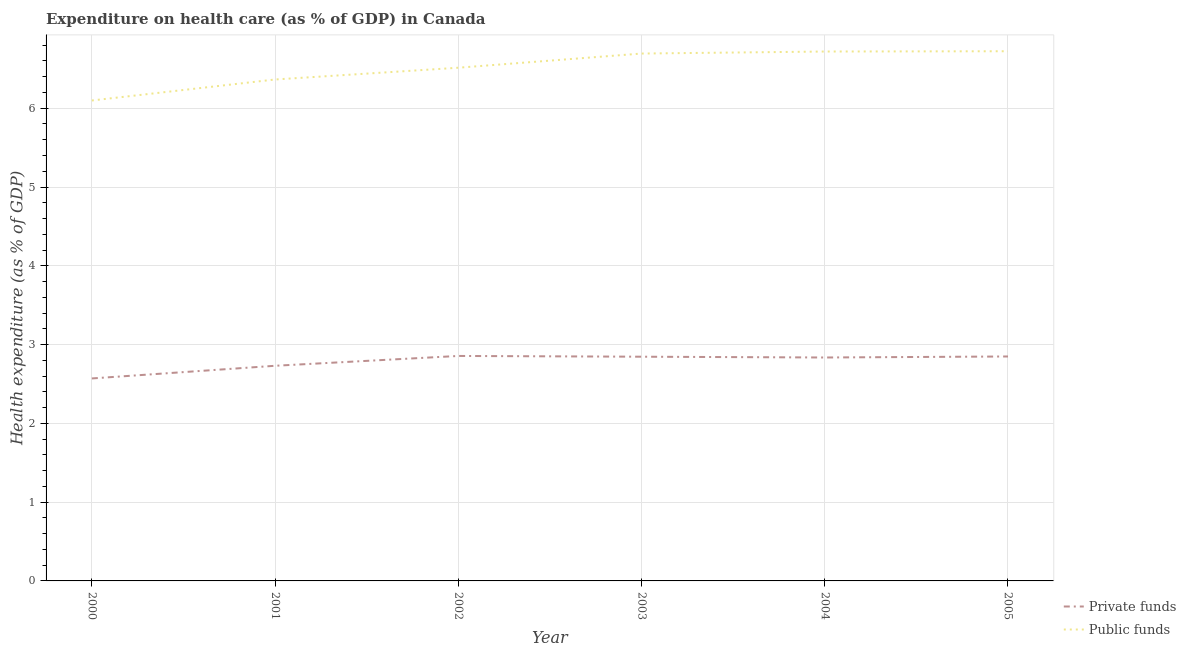What is the amount of public funds spent in healthcare in 2005?
Offer a very short reply. 6.72. Across all years, what is the maximum amount of private funds spent in healthcare?
Your answer should be compact. 2.86. Across all years, what is the minimum amount of private funds spent in healthcare?
Ensure brevity in your answer.  2.57. In which year was the amount of private funds spent in healthcare maximum?
Your response must be concise. 2002. In which year was the amount of public funds spent in healthcare minimum?
Ensure brevity in your answer.  2000. What is the total amount of private funds spent in healthcare in the graph?
Offer a very short reply. 16.69. What is the difference between the amount of private funds spent in healthcare in 2002 and that in 2004?
Make the answer very short. 0.02. What is the difference between the amount of private funds spent in healthcare in 2003 and the amount of public funds spent in healthcare in 2001?
Keep it short and to the point. -3.52. What is the average amount of public funds spent in healthcare per year?
Provide a succinct answer. 6.52. In the year 2000, what is the difference between the amount of private funds spent in healthcare and amount of public funds spent in healthcare?
Your response must be concise. -3.53. In how many years, is the amount of private funds spent in healthcare greater than 0.2 %?
Provide a succinct answer. 6. What is the ratio of the amount of private funds spent in healthcare in 2001 to that in 2002?
Keep it short and to the point. 0.96. Is the amount of public funds spent in healthcare in 2001 less than that in 2002?
Provide a succinct answer. Yes. What is the difference between the highest and the second highest amount of private funds spent in healthcare?
Offer a terse response. 0.01. What is the difference between the highest and the lowest amount of private funds spent in healthcare?
Provide a short and direct response. 0.29. In how many years, is the amount of public funds spent in healthcare greater than the average amount of public funds spent in healthcare taken over all years?
Give a very brief answer. 3. How many years are there in the graph?
Your answer should be compact. 6. Are the values on the major ticks of Y-axis written in scientific E-notation?
Make the answer very short. No. How are the legend labels stacked?
Your response must be concise. Vertical. What is the title of the graph?
Your answer should be very brief. Expenditure on health care (as % of GDP) in Canada. Does "Secondary" appear as one of the legend labels in the graph?
Give a very brief answer. No. What is the label or title of the Y-axis?
Provide a succinct answer. Health expenditure (as % of GDP). What is the Health expenditure (as % of GDP) of Private funds in 2000?
Provide a short and direct response. 2.57. What is the Health expenditure (as % of GDP) in Public funds in 2000?
Offer a very short reply. 6.1. What is the Health expenditure (as % of GDP) of Private funds in 2001?
Keep it short and to the point. 2.73. What is the Health expenditure (as % of GDP) in Public funds in 2001?
Your answer should be very brief. 6.36. What is the Health expenditure (as % of GDP) in Private funds in 2002?
Make the answer very short. 2.86. What is the Health expenditure (as % of GDP) in Public funds in 2002?
Your answer should be very brief. 6.51. What is the Health expenditure (as % of GDP) in Private funds in 2003?
Give a very brief answer. 2.85. What is the Health expenditure (as % of GDP) in Public funds in 2003?
Provide a succinct answer. 6.69. What is the Health expenditure (as % of GDP) of Private funds in 2004?
Your response must be concise. 2.84. What is the Health expenditure (as % of GDP) in Public funds in 2004?
Keep it short and to the point. 6.72. What is the Health expenditure (as % of GDP) of Private funds in 2005?
Ensure brevity in your answer.  2.85. What is the Health expenditure (as % of GDP) in Public funds in 2005?
Give a very brief answer. 6.72. Across all years, what is the maximum Health expenditure (as % of GDP) in Private funds?
Provide a succinct answer. 2.86. Across all years, what is the maximum Health expenditure (as % of GDP) of Public funds?
Your response must be concise. 6.72. Across all years, what is the minimum Health expenditure (as % of GDP) in Private funds?
Make the answer very short. 2.57. Across all years, what is the minimum Health expenditure (as % of GDP) in Public funds?
Keep it short and to the point. 6.1. What is the total Health expenditure (as % of GDP) of Private funds in the graph?
Your response must be concise. 16.69. What is the total Health expenditure (as % of GDP) in Public funds in the graph?
Make the answer very short. 39.12. What is the difference between the Health expenditure (as % of GDP) in Private funds in 2000 and that in 2001?
Provide a succinct answer. -0.16. What is the difference between the Health expenditure (as % of GDP) of Public funds in 2000 and that in 2001?
Provide a succinct answer. -0.27. What is the difference between the Health expenditure (as % of GDP) in Private funds in 2000 and that in 2002?
Ensure brevity in your answer.  -0.29. What is the difference between the Health expenditure (as % of GDP) of Public funds in 2000 and that in 2002?
Provide a short and direct response. -0.42. What is the difference between the Health expenditure (as % of GDP) of Private funds in 2000 and that in 2003?
Your answer should be very brief. -0.28. What is the difference between the Health expenditure (as % of GDP) in Public funds in 2000 and that in 2003?
Your response must be concise. -0.6. What is the difference between the Health expenditure (as % of GDP) of Private funds in 2000 and that in 2004?
Your answer should be compact. -0.27. What is the difference between the Health expenditure (as % of GDP) in Public funds in 2000 and that in 2004?
Provide a succinct answer. -0.62. What is the difference between the Health expenditure (as % of GDP) of Private funds in 2000 and that in 2005?
Your response must be concise. -0.28. What is the difference between the Health expenditure (as % of GDP) of Public funds in 2000 and that in 2005?
Give a very brief answer. -0.63. What is the difference between the Health expenditure (as % of GDP) of Private funds in 2001 and that in 2002?
Provide a short and direct response. -0.12. What is the difference between the Health expenditure (as % of GDP) in Public funds in 2001 and that in 2002?
Ensure brevity in your answer.  -0.15. What is the difference between the Health expenditure (as % of GDP) of Private funds in 2001 and that in 2003?
Your response must be concise. -0.12. What is the difference between the Health expenditure (as % of GDP) in Public funds in 2001 and that in 2003?
Your answer should be very brief. -0.33. What is the difference between the Health expenditure (as % of GDP) in Private funds in 2001 and that in 2004?
Keep it short and to the point. -0.11. What is the difference between the Health expenditure (as % of GDP) in Public funds in 2001 and that in 2004?
Your response must be concise. -0.35. What is the difference between the Health expenditure (as % of GDP) in Private funds in 2001 and that in 2005?
Offer a terse response. -0.12. What is the difference between the Health expenditure (as % of GDP) of Public funds in 2001 and that in 2005?
Give a very brief answer. -0.36. What is the difference between the Health expenditure (as % of GDP) in Private funds in 2002 and that in 2003?
Make the answer very short. 0.01. What is the difference between the Health expenditure (as % of GDP) of Public funds in 2002 and that in 2003?
Provide a succinct answer. -0.18. What is the difference between the Health expenditure (as % of GDP) of Private funds in 2002 and that in 2004?
Keep it short and to the point. 0.02. What is the difference between the Health expenditure (as % of GDP) in Public funds in 2002 and that in 2004?
Your response must be concise. -0.21. What is the difference between the Health expenditure (as % of GDP) of Private funds in 2002 and that in 2005?
Your response must be concise. 0.01. What is the difference between the Health expenditure (as % of GDP) of Public funds in 2002 and that in 2005?
Your answer should be very brief. -0.21. What is the difference between the Health expenditure (as % of GDP) of Private funds in 2003 and that in 2004?
Make the answer very short. 0.01. What is the difference between the Health expenditure (as % of GDP) of Public funds in 2003 and that in 2004?
Offer a very short reply. -0.03. What is the difference between the Health expenditure (as % of GDP) in Private funds in 2003 and that in 2005?
Your answer should be very brief. -0. What is the difference between the Health expenditure (as % of GDP) in Public funds in 2003 and that in 2005?
Offer a very short reply. -0.03. What is the difference between the Health expenditure (as % of GDP) in Private funds in 2004 and that in 2005?
Provide a short and direct response. -0.01. What is the difference between the Health expenditure (as % of GDP) of Public funds in 2004 and that in 2005?
Offer a very short reply. -0. What is the difference between the Health expenditure (as % of GDP) of Private funds in 2000 and the Health expenditure (as % of GDP) of Public funds in 2001?
Your response must be concise. -3.79. What is the difference between the Health expenditure (as % of GDP) in Private funds in 2000 and the Health expenditure (as % of GDP) in Public funds in 2002?
Make the answer very short. -3.94. What is the difference between the Health expenditure (as % of GDP) in Private funds in 2000 and the Health expenditure (as % of GDP) in Public funds in 2003?
Ensure brevity in your answer.  -4.12. What is the difference between the Health expenditure (as % of GDP) in Private funds in 2000 and the Health expenditure (as % of GDP) in Public funds in 2004?
Provide a succinct answer. -4.15. What is the difference between the Health expenditure (as % of GDP) in Private funds in 2000 and the Health expenditure (as % of GDP) in Public funds in 2005?
Give a very brief answer. -4.15. What is the difference between the Health expenditure (as % of GDP) in Private funds in 2001 and the Health expenditure (as % of GDP) in Public funds in 2002?
Give a very brief answer. -3.78. What is the difference between the Health expenditure (as % of GDP) of Private funds in 2001 and the Health expenditure (as % of GDP) of Public funds in 2003?
Make the answer very short. -3.96. What is the difference between the Health expenditure (as % of GDP) of Private funds in 2001 and the Health expenditure (as % of GDP) of Public funds in 2004?
Keep it short and to the point. -3.99. What is the difference between the Health expenditure (as % of GDP) of Private funds in 2001 and the Health expenditure (as % of GDP) of Public funds in 2005?
Give a very brief answer. -3.99. What is the difference between the Health expenditure (as % of GDP) of Private funds in 2002 and the Health expenditure (as % of GDP) of Public funds in 2003?
Offer a terse response. -3.84. What is the difference between the Health expenditure (as % of GDP) of Private funds in 2002 and the Health expenditure (as % of GDP) of Public funds in 2004?
Keep it short and to the point. -3.86. What is the difference between the Health expenditure (as % of GDP) in Private funds in 2002 and the Health expenditure (as % of GDP) in Public funds in 2005?
Give a very brief answer. -3.87. What is the difference between the Health expenditure (as % of GDP) of Private funds in 2003 and the Health expenditure (as % of GDP) of Public funds in 2004?
Give a very brief answer. -3.87. What is the difference between the Health expenditure (as % of GDP) in Private funds in 2003 and the Health expenditure (as % of GDP) in Public funds in 2005?
Your answer should be very brief. -3.88. What is the difference between the Health expenditure (as % of GDP) of Private funds in 2004 and the Health expenditure (as % of GDP) of Public funds in 2005?
Offer a terse response. -3.89. What is the average Health expenditure (as % of GDP) in Private funds per year?
Provide a succinct answer. 2.78. What is the average Health expenditure (as % of GDP) of Public funds per year?
Give a very brief answer. 6.52. In the year 2000, what is the difference between the Health expenditure (as % of GDP) in Private funds and Health expenditure (as % of GDP) in Public funds?
Offer a very short reply. -3.53. In the year 2001, what is the difference between the Health expenditure (as % of GDP) in Private funds and Health expenditure (as % of GDP) in Public funds?
Make the answer very short. -3.63. In the year 2002, what is the difference between the Health expenditure (as % of GDP) in Private funds and Health expenditure (as % of GDP) in Public funds?
Offer a very short reply. -3.66. In the year 2003, what is the difference between the Health expenditure (as % of GDP) of Private funds and Health expenditure (as % of GDP) of Public funds?
Your answer should be very brief. -3.85. In the year 2004, what is the difference between the Health expenditure (as % of GDP) in Private funds and Health expenditure (as % of GDP) in Public funds?
Provide a short and direct response. -3.88. In the year 2005, what is the difference between the Health expenditure (as % of GDP) in Private funds and Health expenditure (as % of GDP) in Public funds?
Your answer should be very brief. -3.87. What is the ratio of the Health expenditure (as % of GDP) in Private funds in 2000 to that in 2001?
Keep it short and to the point. 0.94. What is the ratio of the Health expenditure (as % of GDP) in Public funds in 2000 to that in 2001?
Give a very brief answer. 0.96. What is the ratio of the Health expenditure (as % of GDP) of Public funds in 2000 to that in 2002?
Provide a succinct answer. 0.94. What is the ratio of the Health expenditure (as % of GDP) in Private funds in 2000 to that in 2003?
Give a very brief answer. 0.9. What is the ratio of the Health expenditure (as % of GDP) in Public funds in 2000 to that in 2003?
Your answer should be compact. 0.91. What is the ratio of the Health expenditure (as % of GDP) in Private funds in 2000 to that in 2004?
Keep it short and to the point. 0.91. What is the ratio of the Health expenditure (as % of GDP) in Public funds in 2000 to that in 2004?
Give a very brief answer. 0.91. What is the ratio of the Health expenditure (as % of GDP) in Private funds in 2000 to that in 2005?
Provide a short and direct response. 0.9. What is the ratio of the Health expenditure (as % of GDP) of Public funds in 2000 to that in 2005?
Keep it short and to the point. 0.91. What is the ratio of the Health expenditure (as % of GDP) in Private funds in 2001 to that in 2002?
Provide a short and direct response. 0.96. What is the ratio of the Health expenditure (as % of GDP) in Public funds in 2001 to that in 2002?
Give a very brief answer. 0.98. What is the ratio of the Health expenditure (as % of GDP) in Private funds in 2001 to that in 2003?
Your response must be concise. 0.96. What is the ratio of the Health expenditure (as % of GDP) of Public funds in 2001 to that in 2003?
Keep it short and to the point. 0.95. What is the ratio of the Health expenditure (as % of GDP) in Public funds in 2001 to that in 2004?
Give a very brief answer. 0.95. What is the ratio of the Health expenditure (as % of GDP) in Private funds in 2001 to that in 2005?
Give a very brief answer. 0.96. What is the ratio of the Health expenditure (as % of GDP) in Public funds in 2001 to that in 2005?
Give a very brief answer. 0.95. What is the ratio of the Health expenditure (as % of GDP) of Public funds in 2002 to that in 2003?
Your answer should be very brief. 0.97. What is the ratio of the Health expenditure (as % of GDP) of Private funds in 2002 to that in 2004?
Ensure brevity in your answer.  1.01. What is the ratio of the Health expenditure (as % of GDP) of Public funds in 2002 to that in 2004?
Your response must be concise. 0.97. What is the ratio of the Health expenditure (as % of GDP) in Public funds in 2002 to that in 2005?
Keep it short and to the point. 0.97. What is the ratio of the Health expenditure (as % of GDP) in Private funds in 2003 to that in 2004?
Your response must be concise. 1. What is the ratio of the Health expenditure (as % of GDP) in Public funds in 2003 to that in 2004?
Keep it short and to the point. 1. What is the ratio of the Health expenditure (as % of GDP) in Private funds in 2003 to that in 2005?
Your answer should be very brief. 1. What is the difference between the highest and the second highest Health expenditure (as % of GDP) of Private funds?
Give a very brief answer. 0.01. What is the difference between the highest and the second highest Health expenditure (as % of GDP) of Public funds?
Your answer should be very brief. 0. What is the difference between the highest and the lowest Health expenditure (as % of GDP) in Private funds?
Offer a terse response. 0.29. What is the difference between the highest and the lowest Health expenditure (as % of GDP) of Public funds?
Give a very brief answer. 0.63. 